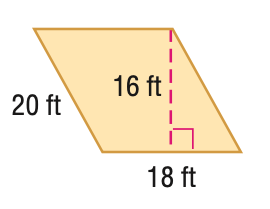Answer the mathemtical geometry problem and directly provide the correct option letter.
Question: Find the area of the parallelogram. Round to the nearest tenth if necessary.
Choices: A: 268 B: 288 C: 320 D: 360 B 